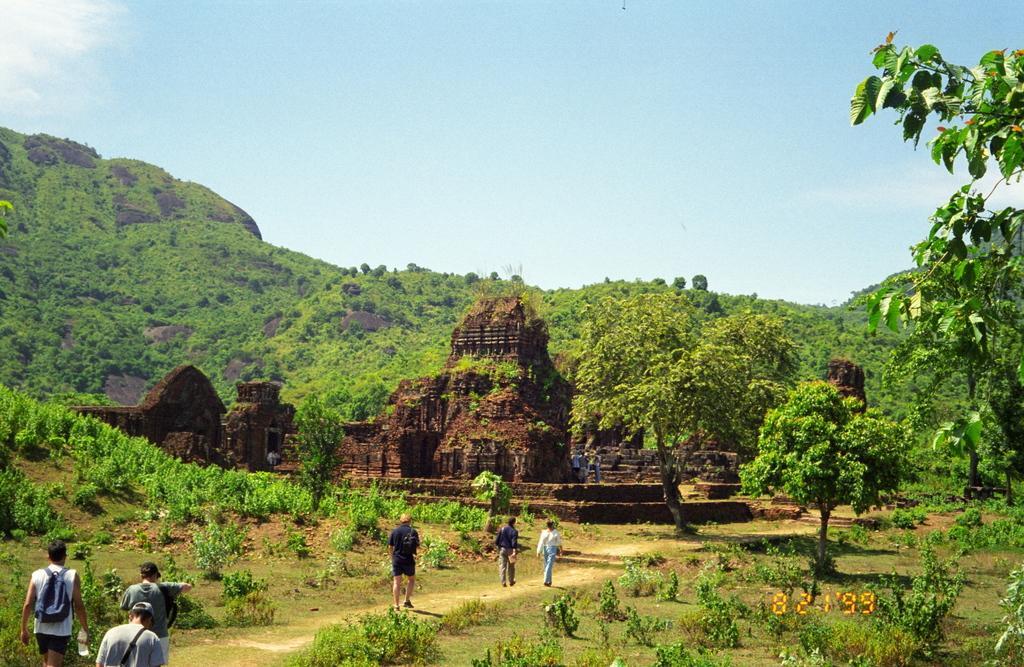Please provide a concise description of this image. In this picture we can see some people walking on the ground, trees, for, mountains and in the background we can see the sky. 